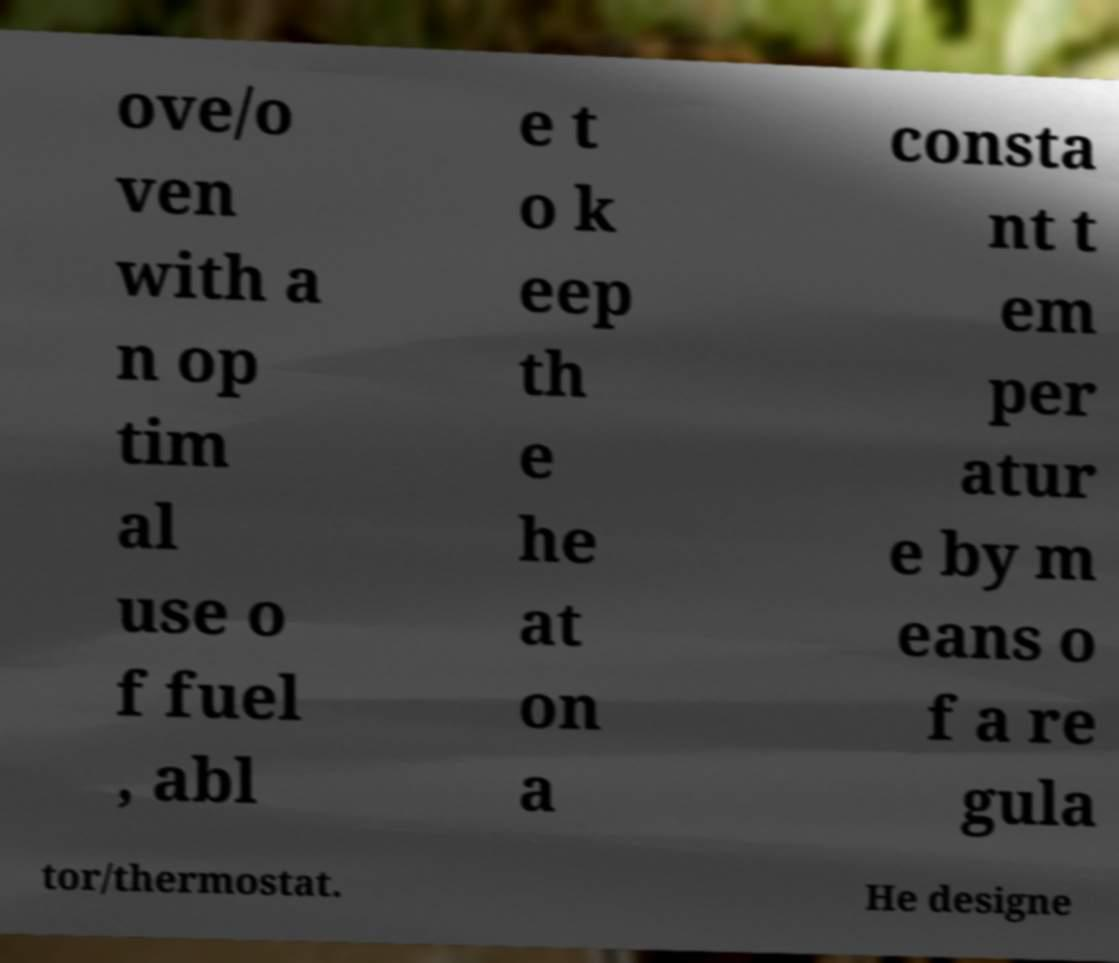Could you assist in decoding the text presented in this image and type it out clearly? ove/o ven with a n op tim al use o f fuel , abl e t o k eep th e he at on a consta nt t em per atur e by m eans o f a re gula tor/thermostat. He designe 